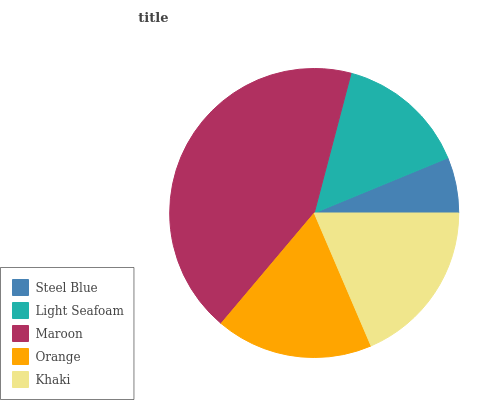Is Steel Blue the minimum?
Answer yes or no. Yes. Is Maroon the maximum?
Answer yes or no. Yes. Is Light Seafoam the minimum?
Answer yes or no. No. Is Light Seafoam the maximum?
Answer yes or no. No. Is Light Seafoam greater than Steel Blue?
Answer yes or no. Yes. Is Steel Blue less than Light Seafoam?
Answer yes or no. Yes. Is Steel Blue greater than Light Seafoam?
Answer yes or no. No. Is Light Seafoam less than Steel Blue?
Answer yes or no. No. Is Orange the high median?
Answer yes or no. Yes. Is Orange the low median?
Answer yes or no. Yes. Is Light Seafoam the high median?
Answer yes or no. No. Is Steel Blue the low median?
Answer yes or no. No. 